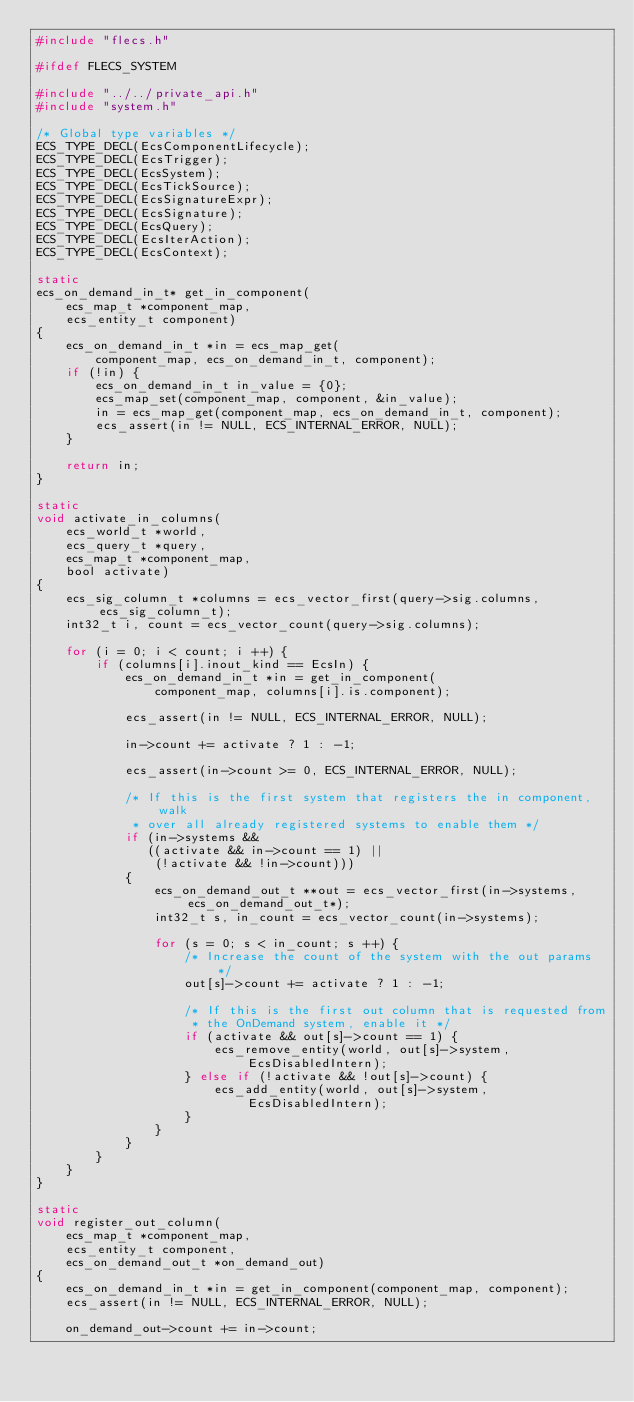Convert code to text. <code><loc_0><loc_0><loc_500><loc_500><_C_>#include "flecs.h"

#ifdef FLECS_SYSTEM

#include "../../private_api.h"
#include "system.h"

/* Global type variables */
ECS_TYPE_DECL(EcsComponentLifecycle);
ECS_TYPE_DECL(EcsTrigger);
ECS_TYPE_DECL(EcsSystem);
ECS_TYPE_DECL(EcsTickSource);
ECS_TYPE_DECL(EcsSignatureExpr);
ECS_TYPE_DECL(EcsSignature);
ECS_TYPE_DECL(EcsQuery);
ECS_TYPE_DECL(EcsIterAction);
ECS_TYPE_DECL(EcsContext);

static
ecs_on_demand_in_t* get_in_component(
    ecs_map_t *component_map,
    ecs_entity_t component)
{
    ecs_on_demand_in_t *in = ecs_map_get(
        component_map, ecs_on_demand_in_t, component);
    if (!in) {
        ecs_on_demand_in_t in_value = {0};
        ecs_map_set(component_map, component, &in_value);
        in = ecs_map_get(component_map, ecs_on_demand_in_t, component);
        ecs_assert(in != NULL, ECS_INTERNAL_ERROR, NULL);
    }

    return in;
}

static
void activate_in_columns(
    ecs_world_t *world,
    ecs_query_t *query,
    ecs_map_t *component_map,
    bool activate)
{
    ecs_sig_column_t *columns = ecs_vector_first(query->sig.columns, ecs_sig_column_t);
    int32_t i, count = ecs_vector_count(query->sig.columns);

    for (i = 0; i < count; i ++) {
        if (columns[i].inout_kind == EcsIn) {
            ecs_on_demand_in_t *in = get_in_component(
                component_map, columns[i].is.component);

            ecs_assert(in != NULL, ECS_INTERNAL_ERROR, NULL);

            in->count += activate ? 1 : -1;

            ecs_assert(in->count >= 0, ECS_INTERNAL_ERROR, NULL);

            /* If this is the first system that registers the in component, walk
             * over all already registered systems to enable them */
            if (in->systems && 
               ((activate && in->count == 1) || 
                (!activate && !in->count))) 
            {
                ecs_on_demand_out_t **out = ecs_vector_first(in->systems, ecs_on_demand_out_t*);
                int32_t s, in_count = ecs_vector_count(in->systems);

                for (s = 0; s < in_count; s ++) {
                    /* Increase the count of the system with the out params */
                    out[s]->count += activate ? 1 : -1;
                    
                    /* If this is the first out column that is requested from
                     * the OnDemand system, enable it */
                    if (activate && out[s]->count == 1) {
                        ecs_remove_entity(world, out[s]->system, EcsDisabledIntern);
                    } else if (!activate && !out[s]->count) {
                        ecs_add_entity(world, out[s]->system, EcsDisabledIntern);             
                    }
                }
            }
        }
    }    
}

static
void register_out_column(
    ecs_map_t *component_map,
    ecs_entity_t component,
    ecs_on_demand_out_t *on_demand_out)
{
    ecs_on_demand_in_t *in = get_in_component(component_map, component);
    ecs_assert(in != NULL, ECS_INTERNAL_ERROR, NULL);

    on_demand_out->count += in->count;</code> 